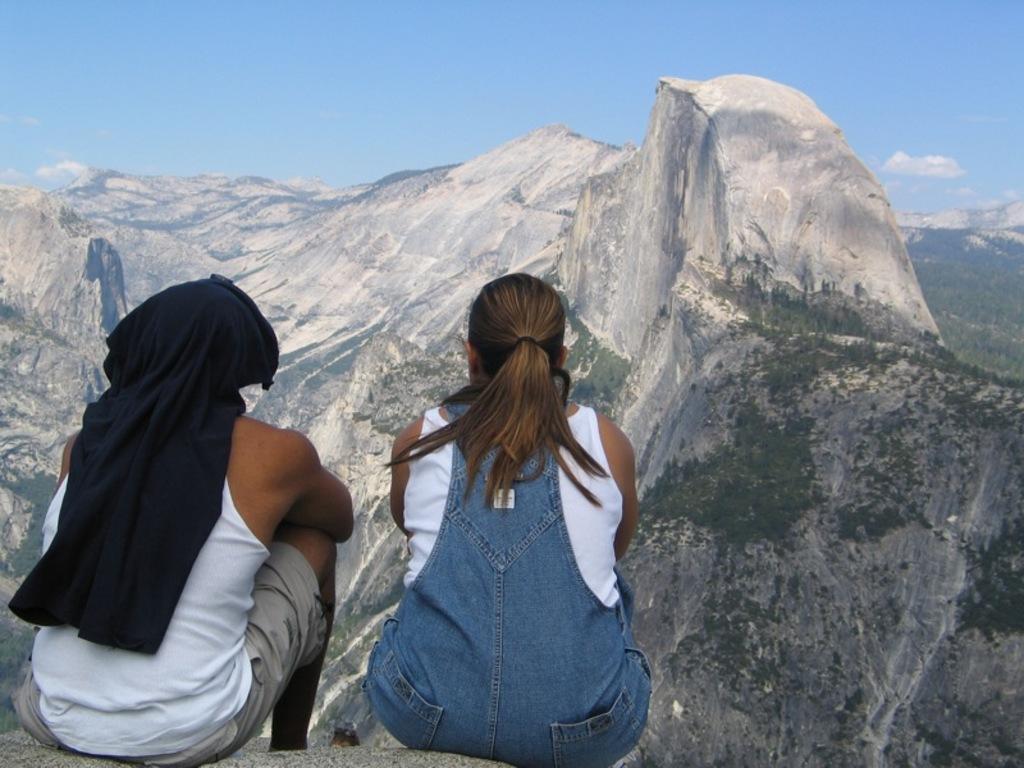In one or two sentences, can you explain what this image depicts? In this image we can see there are two people sitting on the stone. And there are mountains, trees and the sky. 